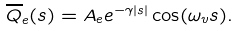Convert formula to latex. <formula><loc_0><loc_0><loc_500><loc_500>\overline { Q } _ { e } ( s ) = A _ { e } e ^ { - \gamma \left | s \right | } \cos ( \omega _ { v } s ) .</formula> 